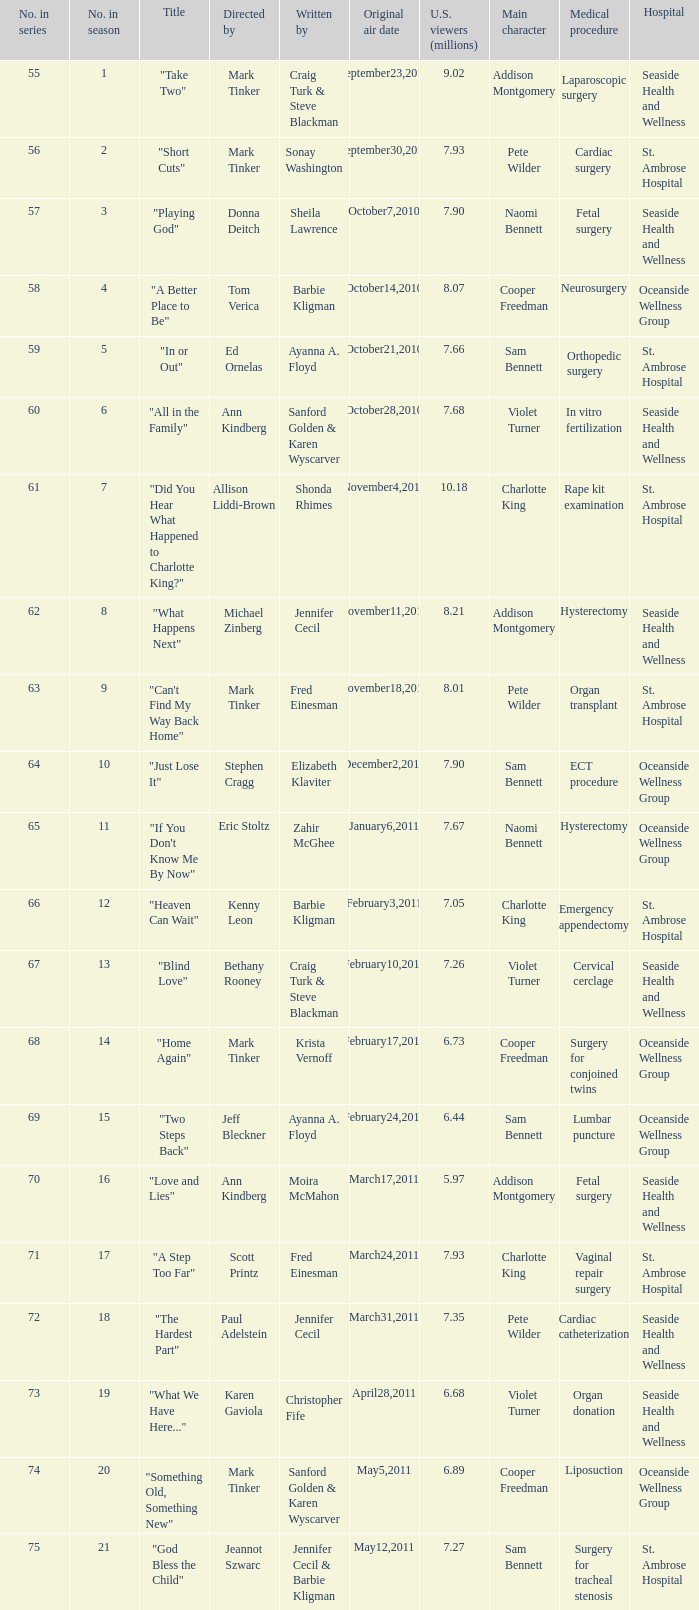What is the earliest numbered episode of the season? 1.0. 